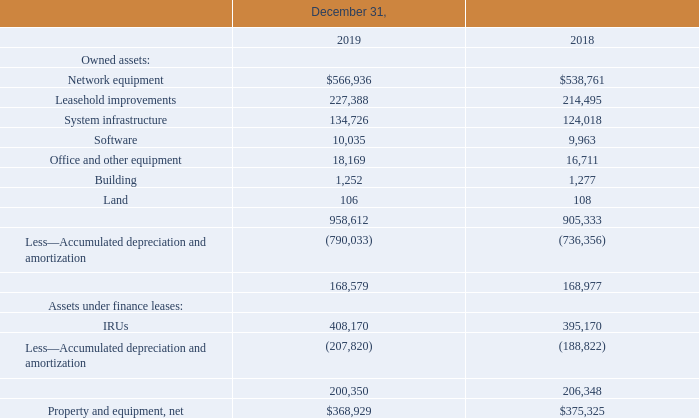2. Property and equipment:
Property and equipment consisted of the following (in thousands):
Depreciation and amortization expense related to property and equipment and finance leases was $80.2 million, $81.2 million and $75.9 million, for 2019, 2018 and 2017, respectively.
The Company capitalizes the compensation cost of employees directly involved with its construction activities. In 2019, 2018 and 2017, the Company capitalized compensation costs of $10.7 million, $10.5 million and $9.7 million respectively. These amounts are included in system infrastructure costs.
Exchange agreement
In 2019, 2018 and 2017 the Company exchanged certain used network equipment and cash consideration for new network equipment. The fair value of the new network equipment received was estimated to be $3.3 million, $3.2 million and $9.1 million resulting in gains of $1.0 million, $1.0 million and $3.9 million respectively. The estimated fair value of the equipment received was based upon the cash consideration price the Company pays for the new network equipment on a standalone basis (Level 3).
Installment payment agreement
The Company has entered into an installment payment agreement (“IPA”) with a vendor. Under the IPA the Company may purchase network equipment in exchange for interest free note obligations each with a twenty-four month term. There are no payments under each note obligation for the first six months followed by eighteen equal installment payments for the remaining eighteen month term. As of December 31, 2019 and December 31, 2018, there was $12.5 million and $11.2 million, respectively, of note obligations outstanding under the IPA, secured by the related equipment. The Company recorded the assets purchased and the present value of the note obligation utilizing an imputed interest rate. The resulting discounts totaling $0.4 million and $0.4 million as of December 31, 2019 and December 31, 2018, respectively, under the note obligations are being amortized over the note term using the effective interest rate method.
What are the respective values of network equipment in 2018 and 2019?
Answer scale should be: thousand. $538,761, $566,936. What are the respective values of leasehold improvements in 2018 and 2019?
Answer scale should be: thousand. 214,495, 227,388. What are the respective values of system infrastructure in 2018 and 2019?
Answer scale should be: thousand. 124,018, 134,726. What is the percentage change in the value of network equipment between 2018 and 2019?
Answer scale should be: percent. (566,936 - 538,761)/538,761 
Answer: 5.23. What is the percentage change in the value of leasehold improvements between 2018 and 2019?
Answer scale should be: percent. (227,388 - 214,495)/214,495 
Answer: 6.01. What is the percentage change in the value of system infrastructure between 2018 and 2019?
Answer scale should be: percent. (134,726 - 124,018 )/124,018  
Answer: 8.63. 